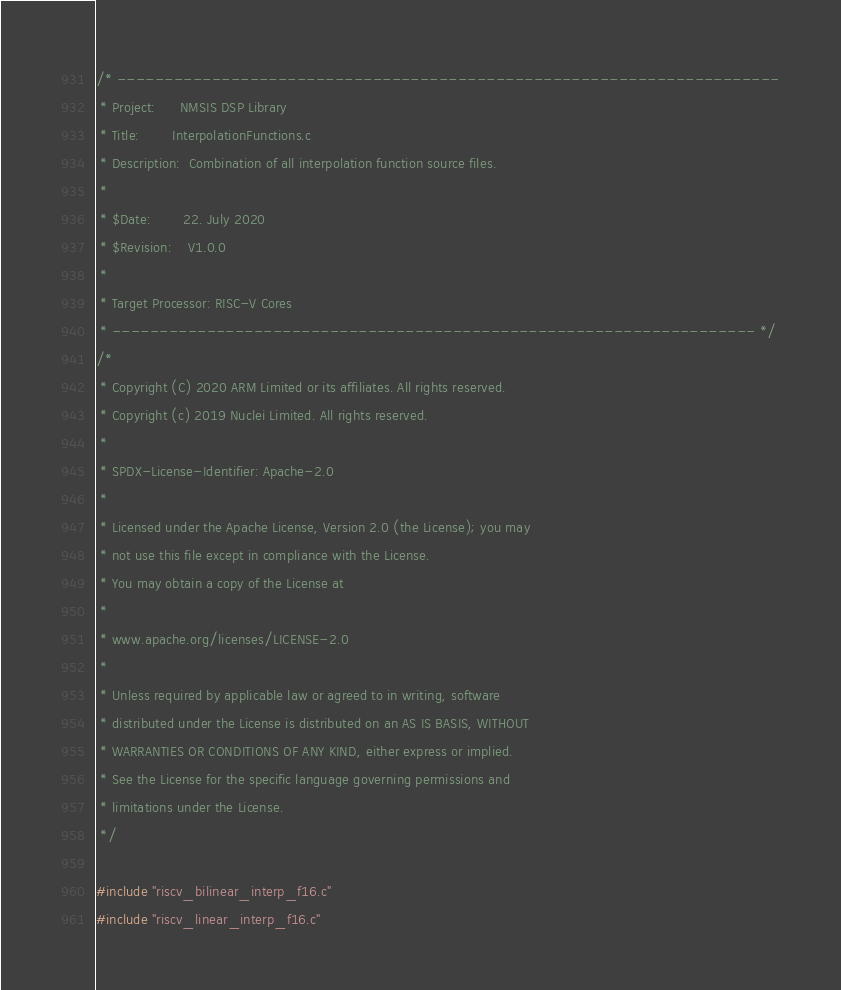Convert code to text. <code><loc_0><loc_0><loc_500><loc_500><_C_>/* ----------------------------------------------------------------------
 * Project:      NMSIS DSP Library
 * Title:        InterpolationFunctions.c
 * Description:  Combination of all interpolation function source files.
 *
 * $Date:        22. July 2020
 * $Revision:    V1.0.0
 *
 * Target Processor: RISC-V Cores
 * -------------------------------------------------------------------- */
/*
 * Copyright (C) 2020 ARM Limited or its affiliates. All rights reserved.
 * Copyright (c) 2019 Nuclei Limited. All rights reserved.
 *
 * SPDX-License-Identifier: Apache-2.0
 *
 * Licensed under the Apache License, Version 2.0 (the License); you may
 * not use this file except in compliance with the License.
 * You may obtain a copy of the License at
 *
 * www.apache.org/licenses/LICENSE-2.0
 *
 * Unless required by applicable law or agreed to in writing, software
 * distributed under the License is distributed on an AS IS BASIS, WITHOUT
 * WARRANTIES OR CONDITIONS OF ANY KIND, either express or implied.
 * See the License for the specific language governing permissions and
 * limitations under the License.
 */

#include "riscv_bilinear_interp_f16.c"
#include "riscv_linear_interp_f16.c"



</code> 